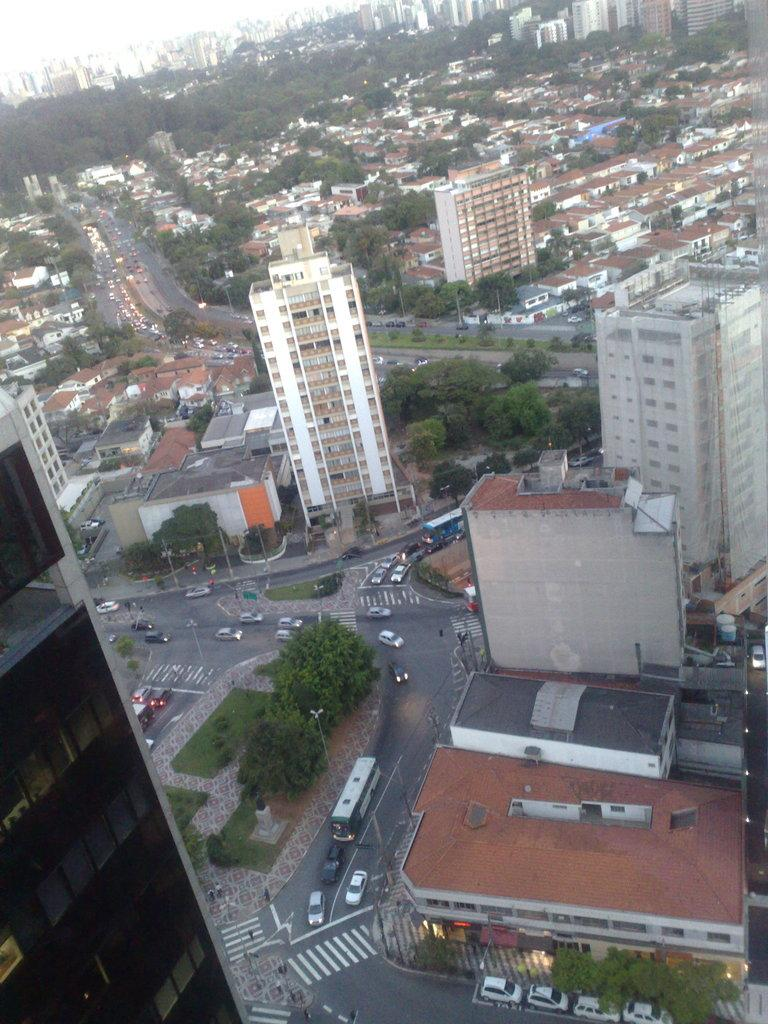What types of structures can be seen in the foreground of the image? There are buildings, houses, and trees in the foreground of the image. What else can be seen in the foreground of the image? There are vehicles on the road and a crowd visible in the foreground of the image. Are there any specific features of the structures in the image? Windows are visible in the image. What can be seen in the top left corner of the image? The sky is visible in the top left corner of the image. Based on the visibility of the sky and the presence of a crowd, what time of day might the image have been taken? The image is likely taken during the day. Can you tell me the name of the writer who is signing autographs in the crowd? There is no writer or autograph signing event depicted in the image. How many cemeteries are visible in the image? There are no cemeteries present in the image. 